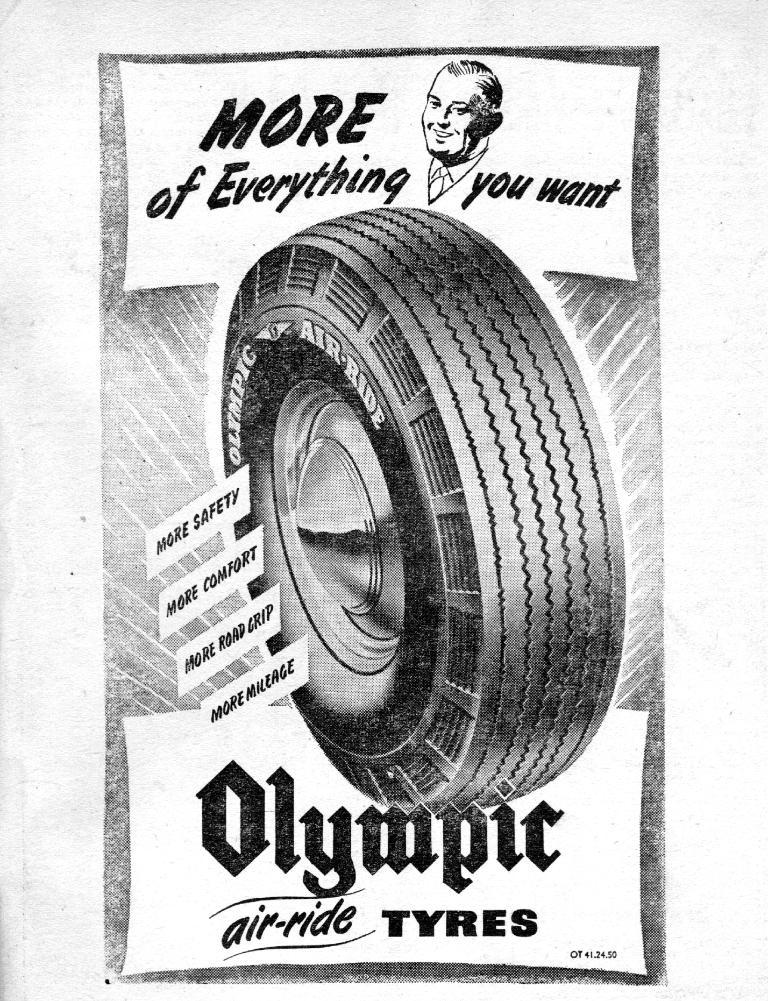What object can be seen in the image? There is a tyre in the image. What else is present in the image besides the tyre? There is text and a person's photo on the top of the image. What type of reaction does the person in the photo have to the tyre in the image? There is no indication of the person's reaction to the tyre in the image, as it only shows their photo on top of the image. 